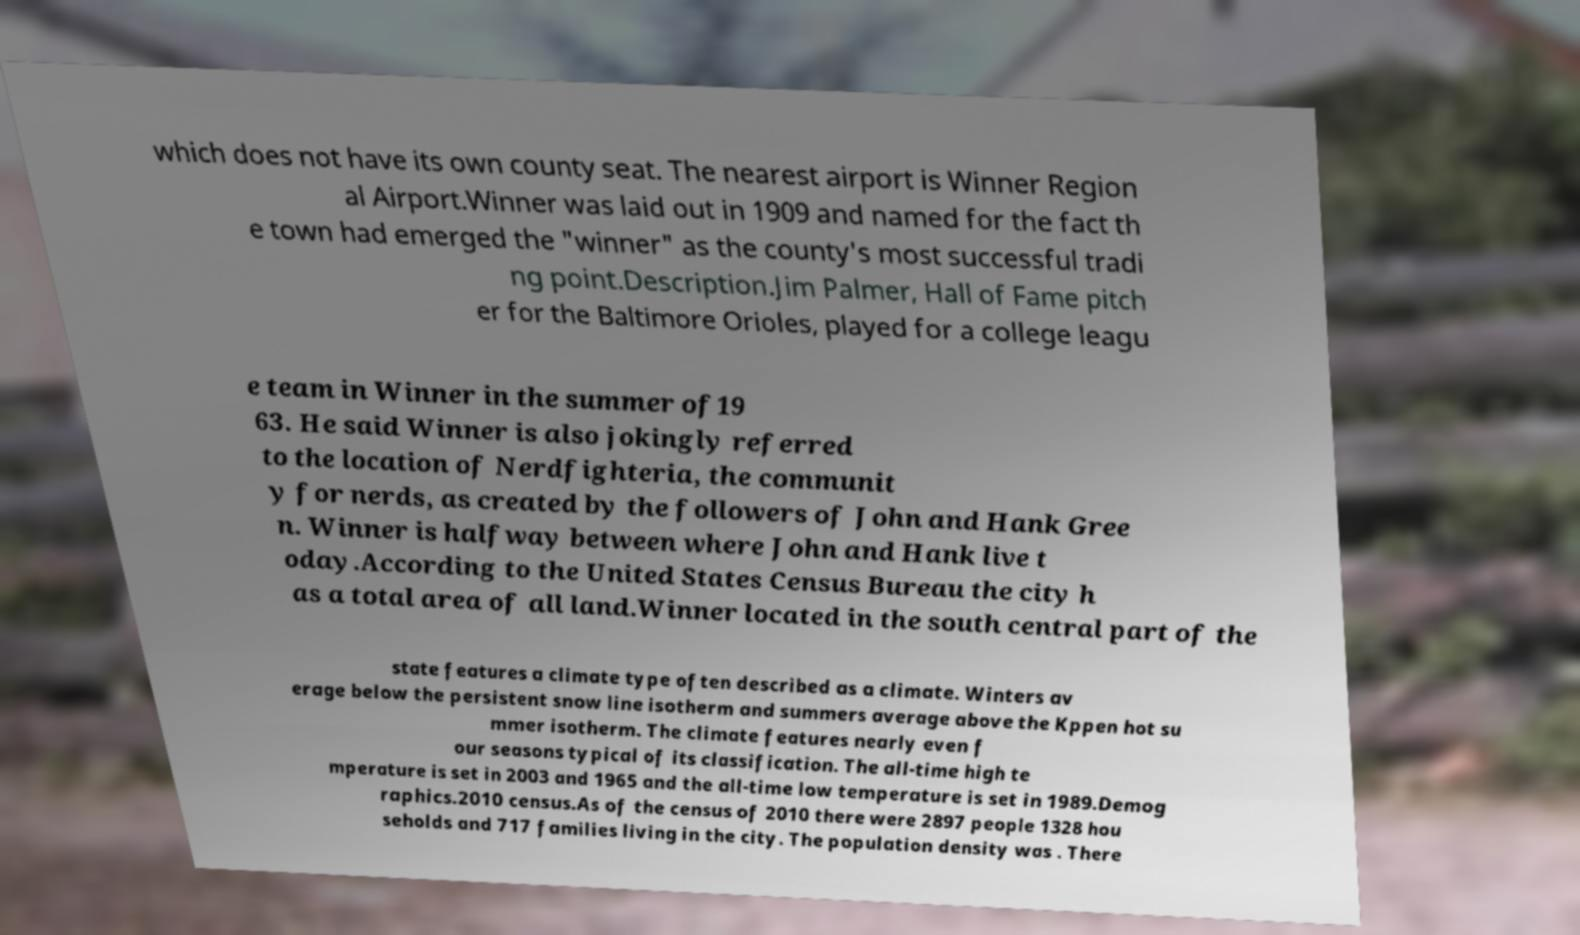Please identify and transcribe the text found in this image. which does not have its own county seat. The nearest airport is Winner Region al Airport.Winner was laid out in 1909 and named for the fact th e town had emerged the "winner" as the county's most successful tradi ng point.Description.Jim Palmer, Hall of Fame pitch er for the Baltimore Orioles, played for a college leagu e team in Winner in the summer of19 63. He said Winner is also jokingly referred to the location of Nerdfighteria, the communit y for nerds, as created by the followers of John and Hank Gree n. Winner is halfway between where John and Hank live t oday.According to the United States Census Bureau the city h as a total area of all land.Winner located in the south central part of the state features a climate type often described as a climate. Winters av erage below the persistent snow line isotherm and summers average above the Kppen hot su mmer isotherm. The climate features nearly even f our seasons typical of its classification. The all-time high te mperature is set in 2003 and 1965 and the all-time low temperature is set in 1989.Demog raphics.2010 census.As of the census of 2010 there were 2897 people 1328 hou seholds and 717 families living in the city. The population density was . There 